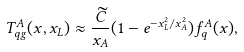Convert formula to latex. <formula><loc_0><loc_0><loc_500><loc_500>T ^ { A } _ { q g } ( x , x _ { L } ) \approx \frac { \widetilde { C } } { x _ { A } } ( 1 - e ^ { - x _ { L } ^ { 2 } / x _ { A } ^ { 2 } } ) f _ { q } ^ { A } ( x ) ,</formula> 